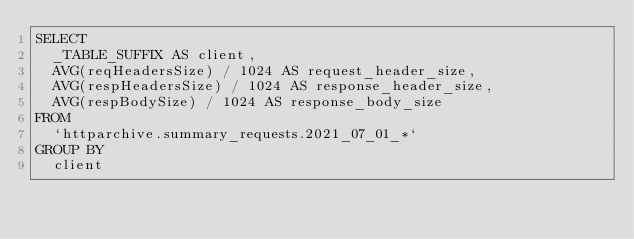<code> <loc_0><loc_0><loc_500><loc_500><_SQL_>SELECT
  _TABLE_SUFFIX AS client,
  AVG(reqHeadersSize) / 1024 AS request_header_size,
  AVG(respHeadersSize) / 1024 AS response_header_size,
  AVG(respBodySize) / 1024 AS response_body_size
FROM
  `httparchive.summary_requests.2021_07_01_*`
GROUP BY
  client
</code> 